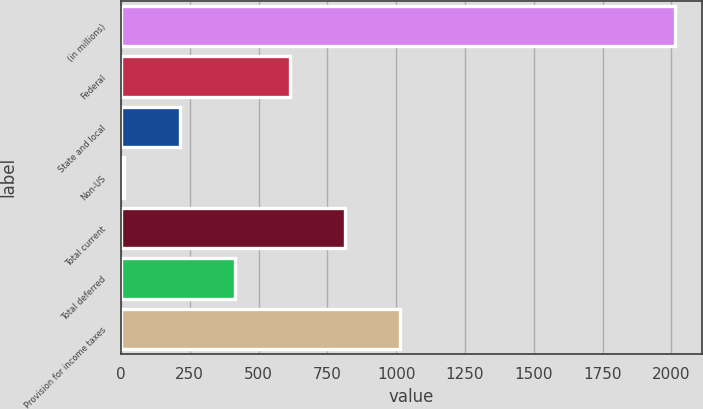<chart> <loc_0><loc_0><loc_500><loc_500><bar_chart><fcel>(in millions)<fcel>Federal<fcel>State and local<fcel>Non-US<fcel>Total current<fcel>Total deferred<fcel>Provision for income taxes<nl><fcel>2012<fcel>612.7<fcel>212.9<fcel>13<fcel>812.6<fcel>412.8<fcel>1012.5<nl></chart> 